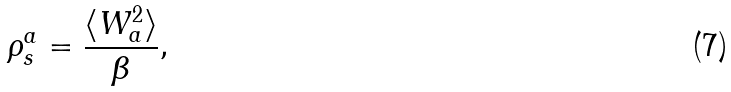Convert formula to latex. <formula><loc_0><loc_0><loc_500><loc_500>\rho _ { s } ^ { a } = \frac { \langle W _ { a } ^ { 2 } \rangle } { \beta } ,</formula> 